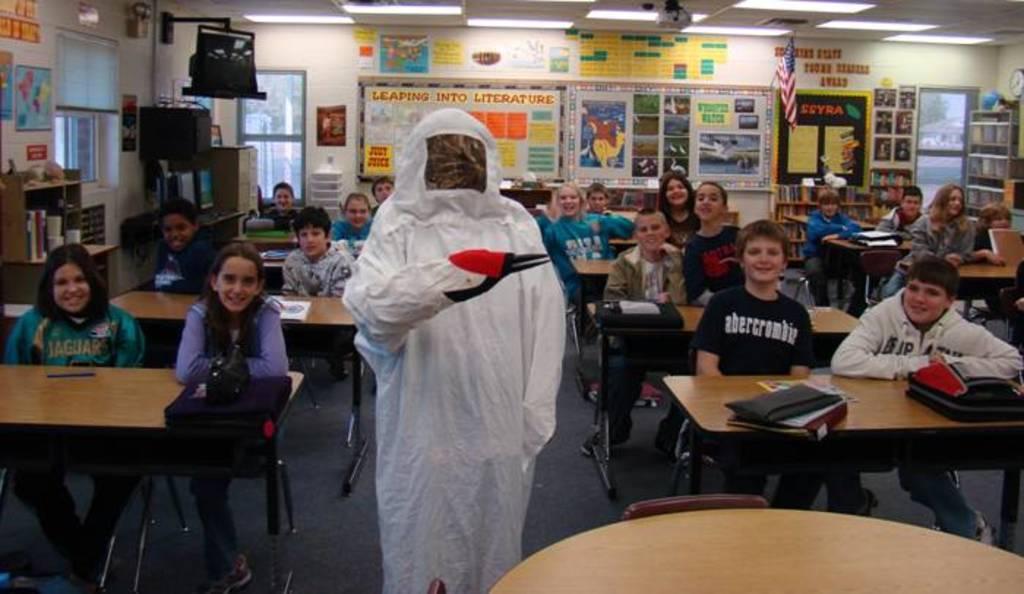In one or two sentences, can you explain what this image depicts? This is looking like a classroom. Many kids are sitting on chairs. In front of them there are tables on table there are bag,packets. In the middle a person is standing wearing a suit. In the background there are posters,painting,board,flag,door, racks with books are there. On the top on ceiling there are lights. 